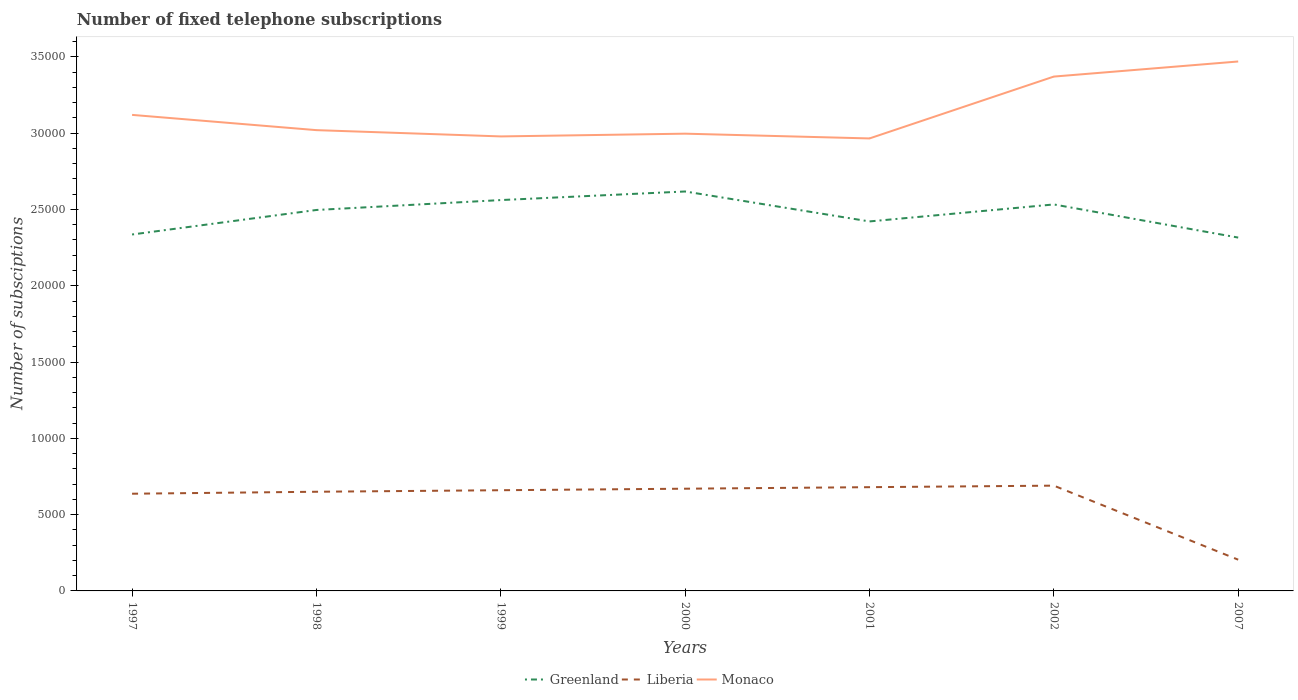How many different coloured lines are there?
Offer a very short reply. 3. Is the number of lines equal to the number of legend labels?
Make the answer very short. Yes. Across all years, what is the maximum number of fixed telephone subscriptions in Greenland?
Keep it short and to the point. 2.32e+04. What is the total number of fixed telephone subscriptions in Liberia in the graph?
Your answer should be compact. 4552. What is the difference between the highest and the second highest number of fixed telephone subscriptions in Greenland?
Provide a short and direct response. 3021. Is the number of fixed telephone subscriptions in Greenland strictly greater than the number of fixed telephone subscriptions in Monaco over the years?
Offer a terse response. Yes. How many years are there in the graph?
Offer a very short reply. 7. What is the difference between two consecutive major ticks on the Y-axis?
Provide a short and direct response. 5000. Are the values on the major ticks of Y-axis written in scientific E-notation?
Give a very brief answer. No. Does the graph contain any zero values?
Ensure brevity in your answer.  No. Does the graph contain grids?
Offer a terse response. No. Where does the legend appear in the graph?
Ensure brevity in your answer.  Bottom center. What is the title of the graph?
Provide a succinct answer. Number of fixed telephone subscriptions. Does "India" appear as one of the legend labels in the graph?
Your response must be concise. No. What is the label or title of the Y-axis?
Your answer should be very brief. Number of subsciptions. What is the Number of subsciptions of Greenland in 1997?
Give a very brief answer. 2.34e+04. What is the Number of subsciptions in Liberia in 1997?
Ensure brevity in your answer.  6371. What is the Number of subsciptions of Monaco in 1997?
Your answer should be very brief. 3.12e+04. What is the Number of subsciptions in Greenland in 1998?
Offer a very short reply. 2.50e+04. What is the Number of subsciptions of Liberia in 1998?
Keep it short and to the point. 6500. What is the Number of subsciptions in Monaco in 1998?
Offer a very short reply. 3.02e+04. What is the Number of subsciptions of Greenland in 1999?
Make the answer very short. 2.56e+04. What is the Number of subsciptions of Liberia in 1999?
Make the answer very short. 6600. What is the Number of subsciptions of Monaco in 1999?
Provide a succinct answer. 2.98e+04. What is the Number of subsciptions of Greenland in 2000?
Offer a terse response. 2.62e+04. What is the Number of subsciptions in Liberia in 2000?
Ensure brevity in your answer.  6700. What is the Number of subsciptions of Monaco in 2000?
Offer a very short reply. 3.00e+04. What is the Number of subsciptions of Greenland in 2001?
Offer a terse response. 2.42e+04. What is the Number of subsciptions of Liberia in 2001?
Your answer should be very brief. 6800. What is the Number of subsciptions of Monaco in 2001?
Provide a succinct answer. 2.97e+04. What is the Number of subsciptions in Greenland in 2002?
Give a very brief answer. 2.53e+04. What is the Number of subsciptions of Liberia in 2002?
Provide a succinct answer. 6900. What is the Number of subsciptions in Monaco in 2002?
Provide a succinct answer. 3.37e+04. What is the Number of subsciptions of Greenland in 2007?
Your answer should be very brief. 2.32e+04. What is the Number of subsciptions of Liberia in 2007?
Ensure brevity in your answer.  2048. What is the Number of subsciptions of Monaco in 2007?
Your answer should be very brief. 3.47e+04. Across all years, what is the maximum Number of subsciptions of Greenland?
Ensure brevity in your answer.  2.62e+04. Across all years, what is the maximum Number of subsciptions of Liberia?
Your response must be concise. 6900. Across all years, what is the maximum Number of subsciptions of Monaco?
Your answer should be very brief. 3.47e+04. Across all years, what is the minimum Number of subsciptions of Greenland?
Your answer should be compact. 2.32e+04. Across all years, what is the minimum Number of subsciptions in Liberia?
Keep it short and to the point. 2048. Across all years, what is the minimum Number of subsciptions of Monaco?
Make the answer very short. 2.97e+04. What is the total Number of subsciptions in Greenland in the graph?
Offer a very short reply. 1.73e+05. What is the total Number of subsciptions in Liberia in the graph?
Give a very brief answer. 4.19e+04. What is the total Number of subsciptions of Monaco in the graph?
Ensure brevity in your answer.  2.19e+05. What is the difference between the Number of subsciptions of Greenland in 1997 and that in 1998?
Make the answer very short. -1607. What is the difference between the Number of subsciptions in Liberia in 1997 and that in 1998?
Provide a succinct answer. -129. What is the difference between the Number of subsciptions in Monaco in 1997 and that in 1998?
Ensure brevity in your answer.  1000. What is the difference between the Number of subsciptions of Greenland in 1997 and that in 1999?
Give a very brief answer. -2256. What is the difference between the Number of subsciptions in Liberia in 1997 and that in 1999?
Give a very brief answer. -229. What is the difference between the Number of subsciptions of Monaco in 1997 and that in 1999?
Your answer should be compact. 1411. What is the difference between the Number of subsciptions in Greenland in 1997 and that in 2000?
Provide a succinct answer. -2819. What is the difference between the Number of subsciptions of Liberia in 1997 and that in 2000?
Make the answer very short. -329. What is the difference between the Number of subsciptions in Monaco in 1997 and that in 2000?
Give a very brief answer. 1231. What is the difference between the Number of subsciptions in Greenland in 1997 and that in 2001?
Ensure brevity in your answer.  -856. What is the difference between the Number of subsciptions of Liberia in 1997 and that in 2001?
Your answer should be very brief. -429. What is the difference between the Number of subsciptions in Monaco in 1997 and that in 2001?
Keep it short and to the point. 1544. What is the difference between the Number of subsciptions of Greenland in 1997 and that in 2002?
Your answer should be compact. -1969. What is the difference between the Number of subsciptions in Liberia in 1997 and that in 2002?
Give a very brief answer. -529. What is the difference between the Number of subsciptions of Monaco in 1997 and that in 2002?
Make the answer very short. -2511. What is the difference between the Number of subsciptions of Greenland in 1997 and that in 2007?
Provide a succinct answer. 202. What is the difference between the Number of subsciptions of Liberia in 1997 and that in 2007?
Your answer should be compact. 4323. What is the difference between the Number of subsciptions in Monaco in 1997 and that in 2007?
Your answer should be compact. -3500. What is the difference between the Number of subsciptions of Greenland in 1998 and that in 1999?
Keep it short and to the point. -649. What is the difference between the Number of subsciptions in Liberia in 1998 and that in 1999?
Provide a short and direct response. -100. What is the difference between the Number of subsciptions in Monaco in 1998 and that in 1999?
Your answer should be very brief. 411. What is the difference between the Number of subsciptions in Greenland in 1998 and that in 2000?
Your response must be concise. -1212. What is the difference between the Number of subsciptions of Liberia in 1998 and that in 2000?
Your response must be concise. -200. What is the difference between the Number of subsciptions in Monaco in 1998 and that in 2000?
Your response must be concise. 231. What is the difference between the Number of subsciptions in Greenland in 1998 and that in 2001?
Offer a very short reply. 751. What is the difference between the Number of subsciptions in Liberia in 1998 and that in 2001?
Give a very brief answer. -300. What is the difference between the Number of subsciptions in Monaco in 1998 and that in 2001?
Offer a terse response. 544. What is the difference between the Number of subsciptions in Greenland in 1998 and that in 2002?
Offer a very short reply. -362. What is the difference between the Number of subsciptions of Liberia in 1998 and that in 2002?
Provide a succinct answer. -400. What is the difference between the Number of subsciptions in Monaco in 1998 and that in 2002?
Your response must be concise. -3511. What is the difference between the Number of subsciptions in Greenland in 1998 and that in 2007?
Make the answer very short. 1809. What is the difference between the Number of subsciptions in Liberia in 1998 and that in 2007?
Offer a terse response. 4452. What is the difference between the Number of subsciptions in Monaco in 1998 and that in 2007?
Provide a short and direct response. -4500. What is the difference between the Number of subsciptions of Greenland in 1999 and that in 2000?
Give a very brief answer. -563. What is the difference between the Number of subsciptions of Liberia in 1999 and that in 2000?
Your answer should be very brief. -100. What is the difference between the Number of subsciptions in Monaco in 1999 and that in 2000?
Give a very brief answer. -180. What is the difference between the Number of subsciptions of Greenland in 1999 and that in 2001?
Make the answer very short. 1400. What is the difference between the Number of subsciptions of Liberia in 1999 and that in 2001?
Ensure brevity in your answer.  -200. What is the difference between the Number of subsciptions of Monaco in 1999 and that in 2001?
Keep it short and to the point. 133. What is the difference between the Number of subsciptions of Greenland in 1999 and that in 2002?
Offer a terse response. 287. What is the difference between the Number of subsciptions of Liberia in 1999 and that in 2002?
Ensure brevity in your answer.  -300. What is the difference between the Number of subsciptions in Monaco in 1999 and that in 2002?
Make the answer very short. -3922. What is the difference between the Number of subsciptions of Greenland in 1999 and that in 2007?
Your response must be concise. 2458. What is the difference between the Number of subsciptions of Liberia in 1999 and that in 2007?
Your answer should be compact. 4552. What is the difference between the Number of subsciptions of Monaco in 1999 and that in 2007?
Provide a succinct answer. -4911. What is the difference between the Number of subsciptions in Greenland in 2000 and that in 2001?
Your response must be concise. 1963. What is the difference between the Number of subsciptions in Liberia in 2000 and that in 2001?
Give a very brief answer. -100. What is the difference between the Number of subsciptions of Monaco in 2000 and that in 2001?
Make the answer very short. 313. What is the difference between the Number of subsciptions in Greenland in 2000 and that in 2002?
Provide a succinct answer. 850. What is the difference between the Number of subsciptions in Liberia in 2000 and that in 2002?
Ensure brevity in your answer.  -200. What is the difference between the Number of subsciptions in Monaco in 2000 and that in 2002?
Keep it short and to the point. -3742. What is the difference between the Number of subsciptions in Greenland in 2000 and that in 2007?
Provide a short and direct response. 3021. What is the difference between the Number of subsciptions of Liberia in 2000 and that in 2007?
Your answer should be compact. 4652. What is the difference between the Number of subsciptions of Monaco in 2000 and that in 2007?
Your answer should be very brief. -4731. What is the difference between the Number of subsciptions in Greenland in 2001 and that in 2002?
Offer a very short reply. -1113. What is the difference between the Number of subsciptions of Liberia in 2001 and that in 2002?
Provide a short and direct response. -100. What is the difference between the Number of subsciptions of Monaco in 2001 and that in 2002?
Your answer should be compact. -4055. What is the difference between the Number of subsciptions of Greenland in 2001 and that in 2007?
Offer a very short reply. 1058. What is the difference between the Number of subsciptions in Liberia in 2001 and that in 2007?
Offer a terse response. 4752. What is the difference between the Number of subsciptions in Monaco in 2001 and that in 2007?
Your response must be concise. -5044. What is the difference between the Number of subsciptions in Greenland in 2002 and that in 2007?
Offer a very short reply. 2171. What is the difference between the Number of subsciptions in Liberia in 2002 and that in 2007?
Provide a short and direct response. 4852. What is the difference between the Number of subsciptions of Monaco in 2002 and that in 2007?
Offer a very short reply. -989. What is the difference between the Number of subsciptions in Greenland in 1997 and the Number of subsciptions in Liberia in 1998?
Your answer should be very brief. 1.69e+04. What is the difference between the Number of subsciptions in Greenland in 1997 and the Number of subsciptions in Monaco in 1998?
Keep it short and to the point. -6839. What is the difference between the Number of subsciptions of Liberia in 1997 and the Number of subsciptions of Monaco in 1998?
Make the answer very short. -2.38e+04. What is the difference between the Number of subsciptions in Greenland in 1997 and the Number of subsciptions in Liberia in 1999?
Ensure brevity in your answer.  1.68e+04. What is the difference between the Number of subsciptions of Greenland in 1997 and the Number of subsciptions of Monaco in 1999?
Offer a terse response. -6428. What is the difference between the Number of subsciptions in Liberia in 1997 and the Number of subsciptions in Monaco in 1999?
Offer a terse response. -2.34e+04. What is the difference between the Number of subsciptions of Greenland in 1997 and the Number of subsciptions of Liberia in 2000?
Ensure brevity in your answer.  1.67e+04. What is the difference between the Number of subsciptions in Greenland in 1997 and the Number of subsciptions in Monaco in 2000?
Make the answer very short. -6608. What is the difference between the Number of subsciptions of Liberia in 1997 and the Number of subsciptions of Monaco in 2000?
Make the answer very short. -2.36e+04. What is the difference between the Number of subsciptions in Greenland in 1997 and the Number of subsciptions in Liberia in 2001?
Keep it short and to the point. 1.66e+04. What is the difference between the Number of subsciptions in Greenland in 1997 and the Number of subsciptions in Monaco in 2001?
Offer a terse response. -6295. What is the difference between the Number of subsciptions in Liberia in 1997 and the Number of subsciptions in Monaco in 2001?
Your answer should be compact. -2.33e+04. What is the difference between the Number of subsciptions of Greenland in 1997 and the Number of subsciptions of Liberia in 2002?
Offer a very short reply. 1.65e+04. What is the difference between the Number of subsciptions of Greenland in 1997 and the Number of subsciptions of Monaco in 2002?
Give a very brief answer. -1.04e+04. What is the difference between the Number of subsciptions of Liberia in 1997 and the Number of subsciptions of Monaco in 2002?
Your answer should be very brief. -2.73e+04. What is the difference between the Number of subsciptions of Greenland in 1997 and the Number of subsciptions of Liberia in 2007?
Offer a terse response. 2.13e+04. What is the difference between the Number of subsciptions in Greenland in 1997 and the Number of subsciptions in Monaco in 2007?
Your answer should be compact. -1.13e+04. What is the difference between the Number of subsciptions of Liberia in 1997 and the Number of subsciptions of Monaco in 2007?
Provide a succinct answer. -2.83e+04. What is the difference between the Number of subsciptions of Greenland in 1998 and the Number of subsciptions of Liberia in 1999?
Your answer should be compact. 1.84e+04. What is the difference between the Number of subsciptions of Greenland in 1998 and the Number of subsciptions of Monaco in 1999?
Your answer should be very brief. -4821. What is the difference between the Number of subsciptions in Liberia in 1998 and the Number of subsciptions in Monaco in 1999?
Give a very brief answer. -2.33e+04. What is the difference between the Number of subsciptions of Greenland in 1998 and the Number of subsciptions of Liberia in 2000?
Offer a terse response. 1.83e+04. What is the difference between the Number of subsciptions in Greenland in 1998 and the Number of subsciptions in Monaco in 2000?
Offer a terse response. -5001. What is the difference between the Number of subsciptions of Liberia in 1998 and the Number of subsciptions of Monaco in 2000?
Offer a terse response. -2.35e+04. What is the difference between the Number of subsciptions in Greenland in 1998 and the Number of subsciptions in Liberia in 2001?
Make the answer very short. 1.82e+04. What is the difference between the Number of subsciptions in Greenland in 1998 and the Number of subsciptions in Monaco in 2001?
Provide a short and direct response. -4688. What is the difference between the Number of subsciptions of Liberia in 1998 and the Number of subsciptions of Monaco in 2001?
Make the answer very short. -2.32e+04. What is the difference between the Number of subsciptions of Greenland in 1998 and the Number of subsciptions of Liberia in 2002?
Your answer should be compact. 1.81e+04. What is the difference between the Number of subsciptions in Greenland in 1998 and the Number of subsciptions in Monaco in 2002?
Keep it short and to the point. -8743. What is the difference between the Number of subsciptions of Liberia in 1998 and the Number of subsciptions of Monaco in 2002?
Your answer should be very brief. -2.72e+04. What is the difference between the Number of subsciptions in Greenland in 1998 and the Number of subsciptions in Liberia in 2007?
Your response must be concise. 2.29e+04. What is the difference between the Number of subsciptions of Greenland in 1998 and the Number of subsciptions of Monaco in 2007?
Your answer should be compact. -9732. What is the difference between the Number of subsciptions of Liberia in 1998 and the Number of subsciptions of Monaco in 2007?
Offer a terse response. -2.82e+04. What is the difference between the Number of subsciptions in Greenland in 1999 and the Number of subsciptions in Liberia in 2000?
Offer a terse response. 1.89e+04. What is the difference between the Number of subsciptions of Greenland in 1999 and the Number of subsciptions of Monaco in 2000?
Offer a very short reply. -4352. What is the difference between the Number of subsciptions of Liberia in 1999 and the Number of subsciptions of Monaco in 2000?
Your answer should be very brief. -2.34e+04. What is the difference between the Number of subsciptions in Greenland in 1999 and the Number of subsciptions in Liberia in 2001?
Keep it short and to the point. 1.88e+04. What is the difference between the Number of subsciptions of Greenland in 1999 and the Number of subsciptions of Monaco in 2001?
Provide a short and direct response. -4039. What is the difference between the Number of subsciptions in Liberia in 1999 and the Number of subsciptions in Monaco in 2001?
Keep it short and to the point. -2.31e+04. What is the difference between the Number of subsciptions in Greenland in 1999 and the Number of subsciptions in Liberia in 2002?
Your answer should be compact. 1.87e+04. What is the difference between the Number of subsciptions in Greenland in 1999 and the Number of subsciptions in Monaco in 2002?
Give a very brief answer. -8094. What is the difference between the Number of subsciptions of Liberia in 1999 and the Number of subsciptions of Monaco in 2002?
Give a very brief answer. -2.71e+04. What is the difference between the Number of subsciptions of Greenland in 1999 and the Number of subsciptions of Liberia in 2007?
Your answer should be compact. 2.36e+04. What is the difference between the Number of subsciptions in Greenland in 1999 and the Number of subsciptions in Monaco in 2007?
Give a very brief answer. -9083. What is the difference between the Number of subsciptions in Liberia in 1999 and the Number of subsciptions in Monaco in 2007?
Give a very brief answer. -2.81e+04. What is the difference between the Number of subsciptions in Greenland in 2000 and the Number of subsciptions in Liberia in 2001?
Provide a succinct answer. 1.94e+04. What is the difference between the Number of subsciptions of Greenland in 2000 and the Number of subsciptions of Monaco in 2001?
Offer a terse response. -3476. What is the difference between the Number of subsciptions in Liberia in 2000 and the Number of subsciptions in Monaco in 2001?
Ensure brevity in your answer.  -2.30e+04. What is the difference between the Number of subsciptions of Greenland in 2000 and the Number of subsciptions of Liberia in 2002?
Your answer should be very brief. 1.93e+04. What is the difference between the Number of subsciptions of Greenland in 2000 and the Number of subsciptions of Monaco in 2002?
Your response must be concise. -7531. What is the difference between the Number of subsciptions in Liberia in 2000 and the Number of subsciptions in Monaco in 2002?
Make the answer very short. -2.70e+04. What is the difference between the Number of subsciptions of Greenland in 2000 and the Number of subsciptions of Liberia in 2007?
Ensure brevity in your answer.  2.41e+04. What is the difference between the Number of subsciptions of Greenland in 2000 and the Number of subsciptions of Monaco in 2007?
Your response must be concise. -8520. What is the difference between the Number of subsciptions of Liberia in 2000 and the Number of subsciptions of Monaco in 2007?
Provide a short and direct response. -2.80e+04. What is the difference between the Number of subsciptions of Greenland in 2001 and the Number of subsciptions of Liberia in 2002?
Ensure brevity in your answer.  1.73e+04. What is the difference between the Number of subsciptions in Greenland in 2001 and the Number of subsciptions in Monaco in 2002?
Give a very brief answer. -9494. What is the difference between the Number of subsciptions of Liberia in 2001 and the Number of subsciptions of Monaco in 2002?
Give a very brief answer. -2.69e+04. What is the difference between the Number of subsciptions in Greenland in 2001 and the Number of subsciptions in Liberia in 2007?
Provide a succinct answer. 2.22e+04. What is the difference between the Number of subsciptions in Greenland in 2001 and the Number of subsciptions in Monaco in 2007?
Provide a succinct answer. -1.05e+04. What is the difference between the Number of subsciptions of Liberia in 2001 and the Number of subsciptions of Monaco in 2007?
Ensure brevity in your answer.  -2.79e+04. What is the difference between the Number of subsciptions of Greenland in 2002 and the Number of subsciptions of Liberia in 2007?
Give a very brief answer. 2.33e+04. What is the difference between the Number of subsciptions in Greenland in 2002 and the Number of subsciptions in Monaco in 2007?
Make the answer very short. -9370. What is the difference between the Number of subsciptions of Liberia in 2002 and the Number of subsciptions of Monaco in 2007?
Ensure brevity in your answer.  -2.78e+04. What is the average Number of subsciptions in Greenland per year?
Make the answer very short. 2.47e+04. What is the average Number of subsciptions of Liberia per year?
Your answer should be very brief. 5988.43. What is the average Number of subsciptions of Monaco per year?
Keep it short and to the point. 3.13e+04. In the year 1997, what is the difference between the Number of subsciptions in Greenland and Number of subsciptions in Liberia?
Ensure brevity in your answer.  1.70e+04. In the year 1997, what is the difference between the Number of subsciptions of Greenland and Number of subsciptions of Monaco?
Your answer should be compact. -7839. In the year 1997, what is the difference between the Number of subsciptions in Liberia and Number of subsciptions in Monaco?
Your response must be concise. -2.48e+04. In the year 1998, what is the difference between the Number of subsciptions of Greenland and Number of subsciptions of Liberia?
Ensure brevity in your answer.  1.85e+04. In the year 1998, what is the difference between the Number of subsciptions in Greenland and Number of subsciptions in Monaco?
Give a very brief answer. -5232. In the year 1998, what is the difference between the Number of subsciptions in Liberia and Number of subsciptions in Monaco?
Make the answer very short. -2.37e+04. In the year 1999, what is the difference between the Number of subsciptions of Greenland and Number of subsciptions of Liberia?
Your answer should be very brief. 1.90e+04. In the year 1999, what is the difference between the Number of subsciptions of Greenland and Number of subsciptions of Monaco?
Your answer should be very brief. -4172. In the year 1999, what is the difference between the Number of subsciptions of Liberia and Number of subsciptions of Monaco?
Make the answer very short. -2.32e+04. In the year 2000, what is the difference between the Number of subsciptions in Greenland and Number of subsciptions in Liberia?
Your response must be concise. 1.95e+04. In the year 2000, what is the difference between the Number of subsciptions in Greenland and Number of subsciptions in Monaco?
Keep it short and to the point. -3789. In the year 2000, what is the difference between the Number of subsciptions of Liberia and Number of subsciptions of Monaco?
Your answer should be very brief. -2.33e+04. In the year 2001, what is the difference between the Number of subsciptions in Greenland and Number of subsciptions in Liberia?
Ensure brevity in your answer.  1.74e+04. In the year 2001, what is the difference between the Number of subsciptions in Greenland and Number of subsciptions in Monaco?
Make the answer very short. -5439. In the year 2001, what is the difference between the Number of subsciptions in Liberia and Number of subsciptions in Monaco?
Give a very brief answer. -2.29e+04. In the year 2002, what is the difference between the Number of subsciptions in Greenland and Number of subsciptions in Liberia?
Keep it short and to the point. 1.84e+04. In the year 2002, what is the difference between the Number of subsciptions in Greenland and Number of subsciptions in Monaco?
Give a very brief answer. -8381. In the year 2002, what is the difference between the Number of subsciptions in Liberia and Number of subsciptions in Monaco?
Provide a short and direct response. -2.68e+04. In the year 2007, what is the difference between the Number of subsciptions of Greenland and Number of subsciptions of Liberia?
Your answer should be very brief. 2.11e+04. In the year 2007, what is the difference between the Number of subsciptions of Greenland and Number of subsciptions of Monaco?
Keep it short and to the point. -1.15e+04. In the year 2007, what is the difference between the Number of subsciptions in Liberia and Number of subsciptions in Monaco?
Provide a short and direct response. -3.27e+04. What is the ratio of the Number of subsciptions in Greenland in 1997 to that in 1998?
Your answer should be very brief. 0.94. What is the ratio of the Number of subsciptions in Liberia in 1997 to that in 1998?
Give a very brief answer. 0.98. What is the ratio of the Number of subsciptions in Monaco in 1997 to that in 1998?
Your answer should be compact. 1.03. What is the ratio of the Number of subsciptions of Greenland in 1997 to that in 1999?
Offer a very short reply. 0.91. What is the ratio of the Number of subsciptions in Liberia in 1997 to that in 1999?
Provide a succinct answer. 0.97. What is the ratio of the Number of subsciptions in Monaco in 1997 to that in 1999?
Provide a succinct answer. 1.05. What is the ratio of the Number of subsciptions in Greenland in 1997 to that in 2000?
Provide a short and direct response. 0.89. What is the ratio of the Number of subsciptions in Liberia in 1997 to that in 2000?
Give a very brief answer. 0.95. What is the ratio of the Number of subsciptions in Monaco in 1997 to that in 2000?
Offer a very short reply. 1.04. What is the ratio of the Number of subsciptions of Greenland in 1997 to that in 2001?
Ensure brevity in your answer.  0.96. What is the ratio of the Number of subsciptions of Liberia in 1997 to that in 2001?
Give a very brief answer. 0.94. What is the ratio of the Number of subsciptions in Monaco in 1997 to that in 2001?
Your answer should be very brief. 1.05. What is the ratio of the Number of subsciptions of Greenland in 1997 to that in 2002?
Keep it short and to the point. 0.92. What is the ratio of the Number of subsciptions of Liberia in 1997 to that in 2002?
Your answer should be very brief. 0.92. What is the ratio of the Number of subsciptions in Monaco in 1997 to that in 2002?
Offer a very short reply. 0.93. What is the ratio of the Number of subsciptions in Greenland in 1997 to that in 2007?
Provide a short and direct response. 1.01. What is the ratio of the Number of subsciptions of Liberia in 1997 to that in 2007?
Your answer should be very brief. 3.11. What is the ratio of the Number of subsciptions in Monaco in 1997 to that in 2007?
Provide a succinct answer. 0.9. What is the ratio of the Number of subsciptions of Greenland in 1998 to that in 1999?
Your response must be concise. 0.97. What is the ratio of the Number of subsciptions in Monaco in 1998 to that in 1999?
Offer a terse response. 1.01. What is the ratio of the Number of subsciptions in Greenland in 1998 to that in 2000?
Make the answer very short. 0.95. What is the ratio of the Number of subsciptions in Liberia in 1998 to that in 2000?
Keep it short and to the point. 0.97. What is the ratio of the Number of subsciptions in Monaco in 1998 to that in 2000?
Offer a terse response. 1.01. What is the ratio of the Number of subsciptions of Greenland in 1998 to that in 2001?
Your answer should be very brief. 1.03. What is the ratio of the Number of subsciptions of Liberia in 1998 to that in 2001?
Make the answer very short. 0.96. What is the ratio of the Number of subsciptions in Monaco in 1998 to that in 2001?
Give a very brief answer. 1.02. What is the ratio of the Number of subsciptions of Greenland in 1998 to that in 2002?
Ensure brevity in your answer.  0.99. What is the ratio of the Number of subsciptions in Liberia in 1998 to that in 2002?
Your answer should be very brief. 0.94. What is the ratio of the Number of subsciptions of Monaco in 1998 to that in 2002?
Your answer should be very brief. 0.9. What is the ratio of the Number of subsciptions of Greenland in 1998 to that in 2007?
Offer a terse response. 1.08. What is the ratio of the Number of subsciptions of Liberia in 1998 to that in 2007?
Your answer should be compact. 3.17. What is the ratio of the Number of subsciptions of Monaco in 1998 to that in 2007?
Make the answer very short. 0.87. What is the ratio of the Number of subsciptions in Greenland in 1999 to that in 2000?
Your answer should be compact. 0.98. What is the ratio of the Number of subsciptions of Liberia in 1999 to that in 2000?
Your response must be concise. 0.99. What is the ratio of the Number of subsciptions in Monaco in 1999 to that in 2000?
Your answer should be very brief. 0.99. What is the ratio of the Number of subsciptions of Greenland in 1999 to that in 2001?
Provide a succinct answer. 1.06. What is the ratio of the Number of subsciptions of Liberia in 1999 to that in 2001?
Give a very brief answer. 0.97. What is the ratio of the Number of subsciptions of Greenland in 1999 to that in 2002?
Your answer should be compact. 1.01. What is the ratio of the Number of subsciptions of Liberia in 1999 to that in 2002?
Give a very brief answer. 0.96. What is the ratio of the Number of subsciptions of Monaco in 1999 to that in 2002?
Your answer should be compact. 0.88. What is the ratio of the Number of subsciptions of Greenland in 1999 to that in 2007?
Provide a succinct answer. 1.11. What is the ratio of the Number of subsciptions of Liberia in 1999 to that in 2007?
Your response must be concise. 3.22. What is the ratio of the Number of subsciptions of Monaco in 1999 to that in 2007?
Your response must be concise. 0.86. What is the ratio of the Number of subsciptions of Greenland in 2000 to that in 2001?
Provide a succinct answer. 1.08. What is the ratio of the Number of subsciptions in Monaco in 2000 to that in 2001?
Provide a short and direct response. 1.01. What is the ratio of the Number of subsciptions in Greenland in 2000 to that in 2002?
Offer a very short reply. 1.03. What is the ratio of the Number of subsciptions of Monaco in 2000 to that in 2002?
Keep it short and to the point. 0.89. What is the ratio of the Number of subsciptions in Greenland in 2000 to that in 2007?
Your answer should be compact. 1.13. What is the ratio of the Number of subsciptions in Liberia in 2000 to that in 2007?
Ensure brevity in your answer.  3.27. What is the ratio of the Number of subsciptions of Monaco in 2000 to that in 2007?
Your response must be concise. 0.86. What is the ratio of the Number of subsciptions of Greenland in 2001 to that in 2002?
Give a very brief answer. 0.96. What is the ratio of the Number of subsciptions of Liberia in 2001 to that in 2002?
Ensure brevity in your answer.  0.99. What is the ratio of the Number of subsciptions of Monaco in 2001 to that in 2002?
Provide a succinct answer. 0.88. What is the ratio of the Number of subsciptions in Greenland in 2001 to that in 2007?
Your response must be concise. 1.05. What is the ratio of the Number of subsciptions of Liberia in 2001 to that in 2007?
Your response must be concise. 3.32. What is the ratio of the Number of subsciptions of Monaco in 2001 to that in 2007?
Offer a terse response. 0.85. What is the ratio of the Number of subsciptions in Greenland in 2002 to that in 2007?
Your answer should be very brief. 1.09. What is the ratio of the Number of subsciptions of Liberia in 2002 to that in 2007?
Keep it short and to the point. 3.37. What is the ratio of the Number of subsciptions of Monaco in 2002 to that in 2007?
Ensure brevity in your answer.  0.97. What is the difference between the highest and the second highest Number of subsciptions of Greenland?
Ensure brevity in your answer.  563. What is the difference between the highest and the second highest Number of subsciptions of Liberia?
Offer a very short reply. 100. What is the difference between the highest and the second highest Number of subsciptions in Monaco?
Make the answer very short. 989. What is the difference between the highest and the lowest Number of subsciptions in Greenland?
Keep it short and to the point. 3021. What is the difference between the highest and the lowest Number of subsciptions in Liberia?
Offer a terse response. 4852. What is the difference between the highest and the lowest Number of subsciptions in Monaco?
Make the answer very short. 5044. 